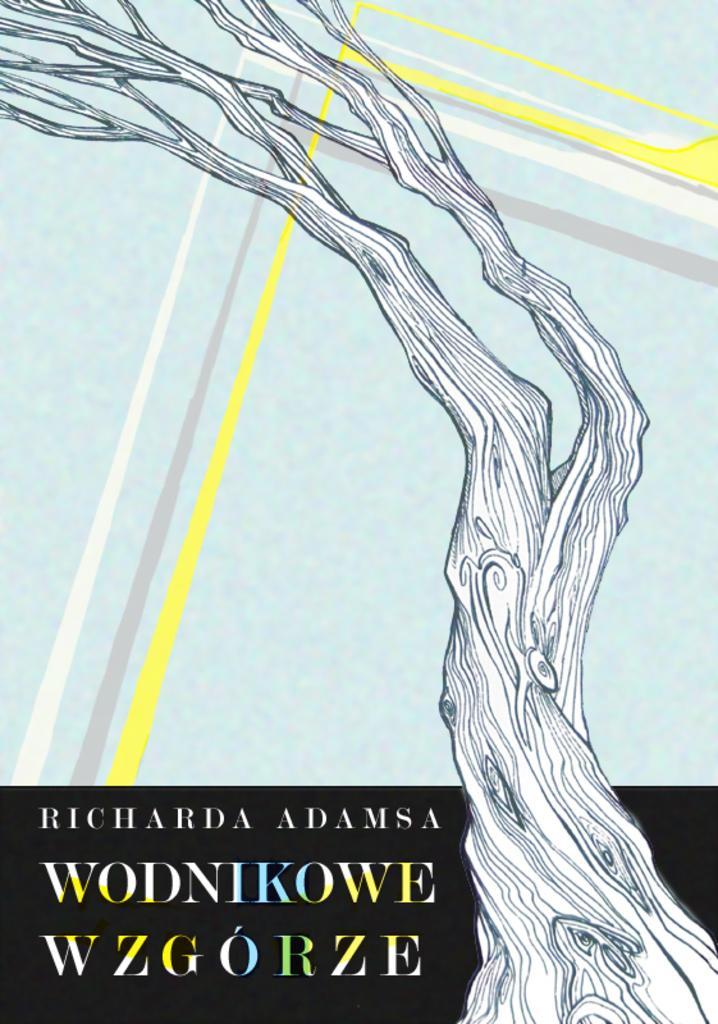Please provide a concise description of this image. The picture shows that it is an illustration, image of a trunk of a tree. 